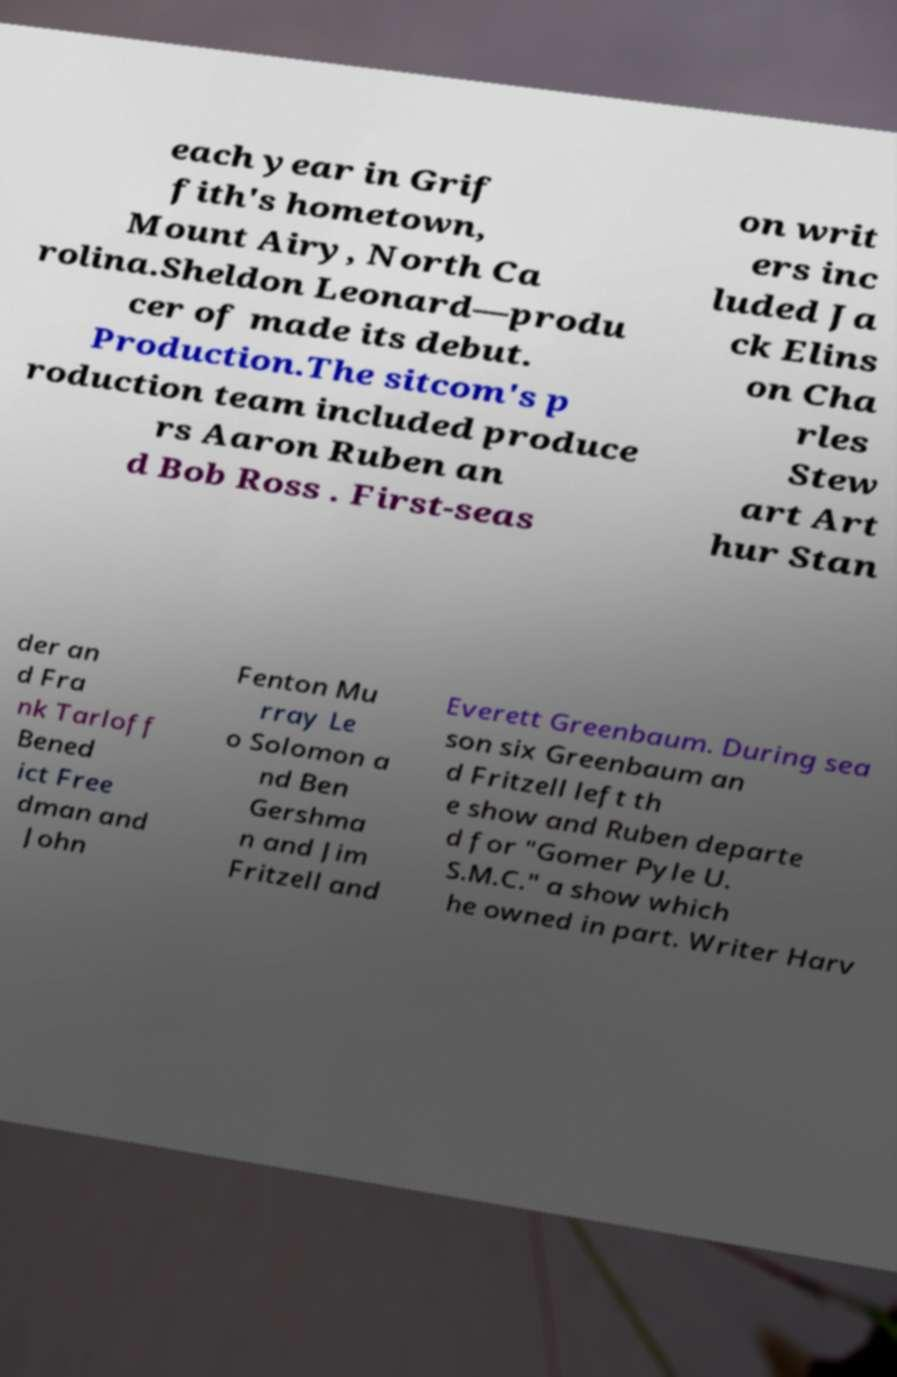There's text embedded in this image that I need extracted. Can you transcribe it verbatim? each year in Grif fith's hometown, Mount Airy, North Ca rolina.Sheldon Leonard—produ cer of made its debut. Production.The sitcom's p roduction team included produce rs Aaron Ruben an d Bob Ross . First-seas on writ ers inc luded Ja ck Elins on Cha rles Stew art Art hur Stan der an d Fra nk Tarloff Bened ict Free dman and John Fenton Mu rray Le o Solomon a nd Ben Gershma n and Jim Fritzell and Everett Greenbaum. During sea son six Greenbaum an d Fritzell left th e show and Ruben departe d for "Gomer Pyle U. S.M.C." a show which he owned in part. Writer Harv 